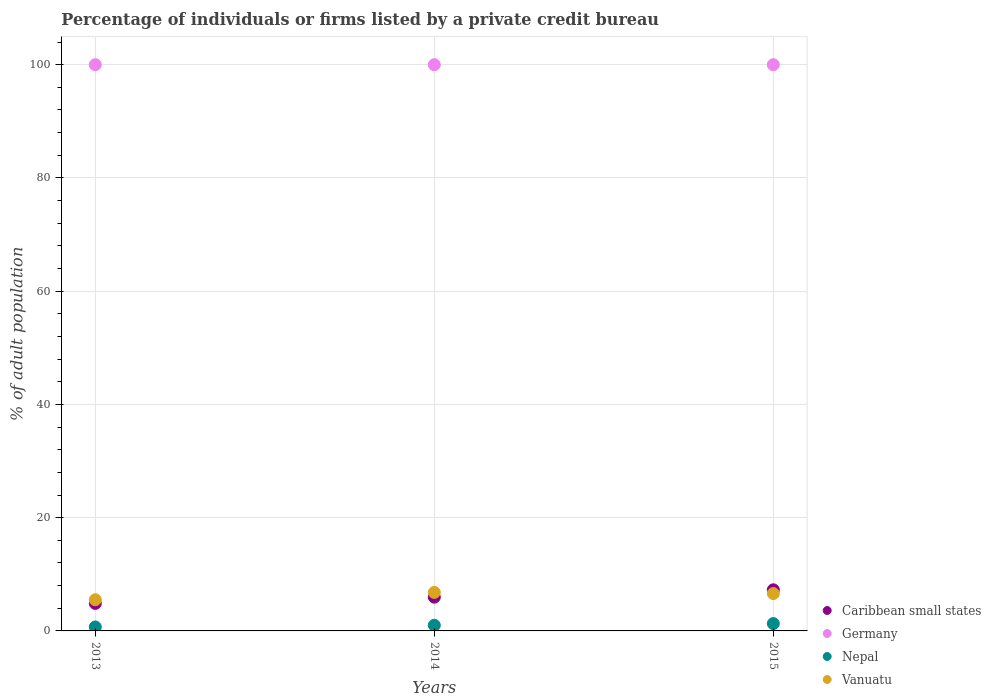How many different coloured dotlines are there?
Offer a terse response. 4. Is the number of dotlines equal to the number of legend labels?
Keep it short and to the point. Yes. Across all years, what is the minimum percentage of population listed by a private credit bureau in Vanuatu?
Provide a short and direct response. 5.5. In which year was the percentage of population listed by a private credit bureau in Caribbean small states maximum?
Give a very brief answer. 2015. What is the total percentage of population listed by a private credit bureau in Germany in the graph?
Give a very brief answer. 300. What is the difference between the percentage of population listed by a private credit bureau in Caribbean small states in 2014 and that in 2015?
Your answer should be compact. -1.3. What is the average percentage of population listed by a private credit bureau in Vanuatu per year?
Provide a short and direct response. 6.3. In the year 2013, what is the difference between the percentage of population listed by a private credit bureau in Germany and percentage of population listed by a private credit bureau in Vanuatu?
Offer a very short reply. 94.5. In how many years, is the percentage of population listed by a private credit bureau in Caribbean small states greater than 12 %?
Provide a short and direct response. 0. What is the ratio of the percentage of population listed by a private credit bureau in Nepal in 2014 to that in 2015?
Provide a short and direct response. 0.77. Is the difference between the percentage of population listed by a private credit bureau in Germany in 2013 and 2014 greater than the difference between the percentage of population listed by a private credit bureau in Vanuatu in 2013 and 2014?
Offer a very short reply. Yes. What is the difference between the highest and the second highest percentage of population listed by a private credit bureau in Caribbean small states?
Offer a terse response. 1.3. What is the difference between the highest and the lowest percentage of population listed by a private credit bureau in Caribbean small states?
Your answer should be very brief. 2.4. Is the sum of the percentage of population listed by a private credit bureau in Germany in 2013 and 2015 greater than the maximum percentage of population listed by a private credit bureau in Vanuatu across all years?
Give a very brief answer. Yes. Is it the case that in every year, the sum of the percentage of population listed by a private credit bureau in Caribbean small states and percentage of population listed by a private credit bureau in Vanuatu  is greater than the sum of percentage of population listed by a private credit bureau in Nepal and percentage of population listed by a private credit bureau in Germany?
Make the answer very short. No. Is the percentage of population listed by a private credit bureau in Caribbean small states strictly greater than the percentage of population listed by a private credit bureau in Nepal over the years?
Make the answer very short. Yes. Is the percentage of population listed by a private credit bureau in Germany strictly less than the percentage of population listed by a private credit bureau in Vanuatu over the years?
Your answer should be very brief. No. How many dotlines are there?
Make the answer very short. 4. How many years are there in the graph?
Offer a terse response. 3. What is the difference between two consecutive major ticks on the Y-axis?
Make the answer very short. 20. Where does the legend appear in the graph?
Ensure brevity in your answer.  Bottom right. What is the title of the graph?
Offer a very short reply. Percentage of individuals or firms listed by a private credit bureau. Does "Saudi Arabia" appear as one of the legend labels in the graph?
Give a very brief answer. No. What is the label or title of the X-axis?
Provide a succinct answer. Years. What is the label or title of the Y-axis?
Offer a terse response. % of adult population. What is the % of adult population of Caribbean small states in 2013?
Offer a very short reply. 4.86. What is the % of adult population in Germany in 2013?
Keep it short and to the point. 100. What is the % of adult population in Caribbean small states in 2014?
Offer a very short reply. 5.96. What is the % of adult population in Germany in 2014?
Provide a succinct answer. 100. What is the % of adult population of Vanuatu in 2014?
Keep it short and to the point. 6.8. What is the % of adult population in Caribbean small states in 2015?
Provide a succinct answer. 7.26. What is the % of adult population in Germany in 2015?
Make the answer very short. 100. What is the % of adult population in Nepal in 2015?
Your answer should be very brief. 1.3. Across all years, what is the maximum % of adult population in Caribbean small states?
Your answer should be very brief. 7.26. Across all years, what is the maximum % of adult population of Nepal?
Give a very brief answer. 1.3. Across all years, what is the maximum % of adult population in Vanuatu?
Your response must be concise. 6.8. Across all years, what is the minimum % of adult population in Caribbean small states?
Your response must be concise. 4.86. What is the total % of adult population of Caribbean small states in the graph?
Offer a very short reply. 18.08. What is the total % of adult population of Germany in the graph?
Ensure brevity in your answer.  300. What is the total % of adult population in Vanuatu in the graph?
Make the answer very short. 18.9. What is the difference between the % of adult population in Caribbean small states in 2013 and that in 2014?
Your answer should be very brief. -1.1. What is the difference between the % of adult population in Vanuatu in 2014 and that in 2015?
Give a very brief answer. 0.2. What is the difference between the % of adult population in Caribbean small states in 2013 and the % of adult population in Germany in 2014?
Provide a succinct answer. -95.14. What is the difference between the % of adult population in Caribbean small states in 2013 and the % of adult population in Nepal in 2014?
Provide a succinct answer. 3.86. What is the difference between the % of adult population in Caribbean small states in 2013 and the % of adult population in Vanuatu in 2014?
Keep it short and to the point. -1.94. What is the difference between the % of adult population of Germany in 2013 and the % of adult population of Vanuatu in 2014?
Provide a short and direct response. 93.2. What is the difference between the % of adult population in Nepal in 2013 and the % of adult population in Vanuatu in 2014?
Provide a short and direct response. -6.1. What is the difference between the % of adult population of Caribbean small states in 2013 and the % of adult population of Germany in 2015?
Offer a very short reply. -95.14. What is the difference between the % of adult population in Caribbean small states in 2013 and the % of adult population in Nepal in 2015?
Provide a short and direct response. 3.56. What is the difference between the % of adult population in Caribbean small states in 2013 and the % of adult population in Vanuatu in 2015?
Offer a terse response. -1.74. What is the difference between the % of adult population in Germany in 2013 and the % of adult population in Nepal in 2015?
Your answer should be compact. 98.7. What is the difference between the % of adult population of Germany in 2013 and the % of adult population of Vanuatu in 2015?
Give a very brief answer. 93.4. What is the difference between the % of adult population of Nepal in 2013 and the % of adult population of Vanuatu in 2015?
Keep it short and to the point. -5.9. What is the difference between the % of adult population in Caribbean small states in 2014 and the % of adult population in Germany in 2015?
Your answer should be very brief. -94.04. What is the difference between the % of adult population in Caribbean small states in 2014 and the % of adult population in Nepal in 2015?
Your answer should be compact. 4.66. What is the difference between the % of adult population in Caribbean small states in 2014 and the % of adult population in Vanuatu in 2015?
Offer a very short reply. -0.64. What is the difference between the % of adult population in Germany in 2014 and the % of adult population in Nepal in 2015?
Ensure brevity in your answer.  98.7. What is the difference between the % of adult population in Germany in 2014 and the % of adult population in Vanuatu in 2015?
Make the answer very short. 93.4. What is the difference between the % of adult population of Nepal in 2014 and the % of adult population of Vanuatu in 2015?
Ensure brevity in your answer.  -5.6. What is the average % of adult population in Caribbean small states per year?
Make the answer very short. 6.03. What is the average % of adult population of Nepal per year?
Offer a very short reply. 1. What is the average % of adult population in Vanuatu per year?
Offer a very short reply. 6.3. In the year 2013, what is the difference between the % of adult population of Caribbean small states and % of adult population of Germany?
Your response must be concise. -95.14. In the year 2013, what is the difference between the % of adult population of Caribbean small states and % of adult population of Nepal?
Ensure brevity in your answer.  4.16. In the year 2013, what is the difference between the % of adult population of Caribbean small states and % of adult population of Vanuatu?
Provide a short and direct response. -0.64. In the year 2013, what is the difference between the % of adult population of Germany and % of adult population of Nepal?
Your answer should be very brief. 99.3. In the year 2013, what is the difference between the % of adult population in Germany and % of adult population in Vanuatu?
Your response must be concise. 94.5. In the year 2013, what is the difference between the % of adult population in Nepal and % of adult population in Vanuatu?
Provide a succinct answer. -4.8. In the year 2014, what is the difference between the % of adult population of Caribbean small states and % of adult population of Germany?
Ensure brevity in your answer.  -94.04. In the year 2014, what is the difference between the % of adult population in Caribbean small states and % of adult population in Nepal?
Offer a terse response. 4.96. In the year 2014, what is the difference between the % of adult population in Caribbean small states and % of adult population in Vanuatu?
Your answer should be very brief. -0.84. In the year 2014, what is the difference between the % of adult population of Germany and % of adult population of Vanuatu?
Ensure brevity in your answer.  93.2. In the year 2014, what is the difference between the % of adult population of Nepal and % of adult population of Vanuatu?
Give a very brief answer. -5.8. In the year 2015, what is the difference between the % of adult population of Caribbean small states and % of adult population of Germany?
Provide a succinct answer. -92.74. In the year 2015, what is the difference between the % of adult population in Caribbean small states and % of adult population in Nepal?
Provide a succinct answer. 5.96. In the year 2015, what is the difference between the % of adult population of Caribbean small states and % of adult population of Vanuatu?
Your answer should be compact. 0.66. In the year 2015, what is the difference between the % of adult population in Germany and % of adult population in Nepal?
Make the answer very short. 98.7. In the year 2015, what is the difference between the % of adult population of Germany and % of adult population of Vanuatu?
Provide a short and direct response. 93.4. In the year 2015, what is the difference between the % of adult population of Nepal and % of adult population of Vanuatu?
Your response must be concise. -5.3. What is the ratio of the % of adult population in Caribbean small states in 2013 to that in 2014?
Offer a very short reply. 0.82. What is the ratio of the % of adult population of Germany in 2013 to that in 2014?
Make the answer very short. 1. What is the ratio of the % of adult population in Vanuatu in 2013 to that in 2014?
Make the answer very short. 0.81. What is the ratio of the % of adult population of Caribbean small states in 2013 to that in 2015?
Ensure brevity in your answer.  0.67. What is the ratio of the % of adult population of Nepal in 2013 to that in 2015?
Provide a short and direct response. 0.54. What is the ratio of the % of adult population of Vanuatu in 2013 to that in 2015?
Make the answer very short. 0.83. What is the ratio of the % of adult population of Caribbean small states in 2014 to that in 2015?
Offer a terse response. 0.82. What is the ratio of the % of adult population in Nepal in 2014 to that in 2015?
Keep it short and to the point. 0.77. What is the ratio of the % of adult population in Vanuatu in 2014 to that in 2015?
Ensure brevity in your answer.  1.03. What is the difference between the highest and the second highest % of adult population of Caribbean small states?
Make the answer very short. 1.3. What is the difference between the highest and the second highest % of adult population in Germany?
Offer a terse response. 0. What is the difference between the highest and the second highest % of adult population of Nepal?
Your response must be concise. 0.3. What is the difference between the highest and the second highest % of adult population in Vanuatu?
Offer a terse response. 0.2. What is the difference between the highest and the lowest % of adult population in Germany?
Provide a succinct answer. 0. 